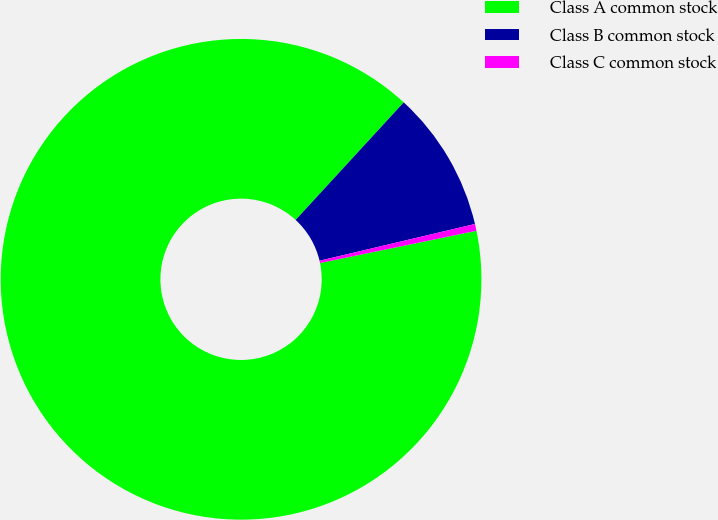Convert chart. <chart><loc_0><loc_0><loc_500><loc_500><pie_chart><fcel>Class A common stock<fcel>Class B common stock<fcel>Class C common stock<nl><fcel>90.06%<fcel>9.47%<fcel>0.46%<nl></chart> 